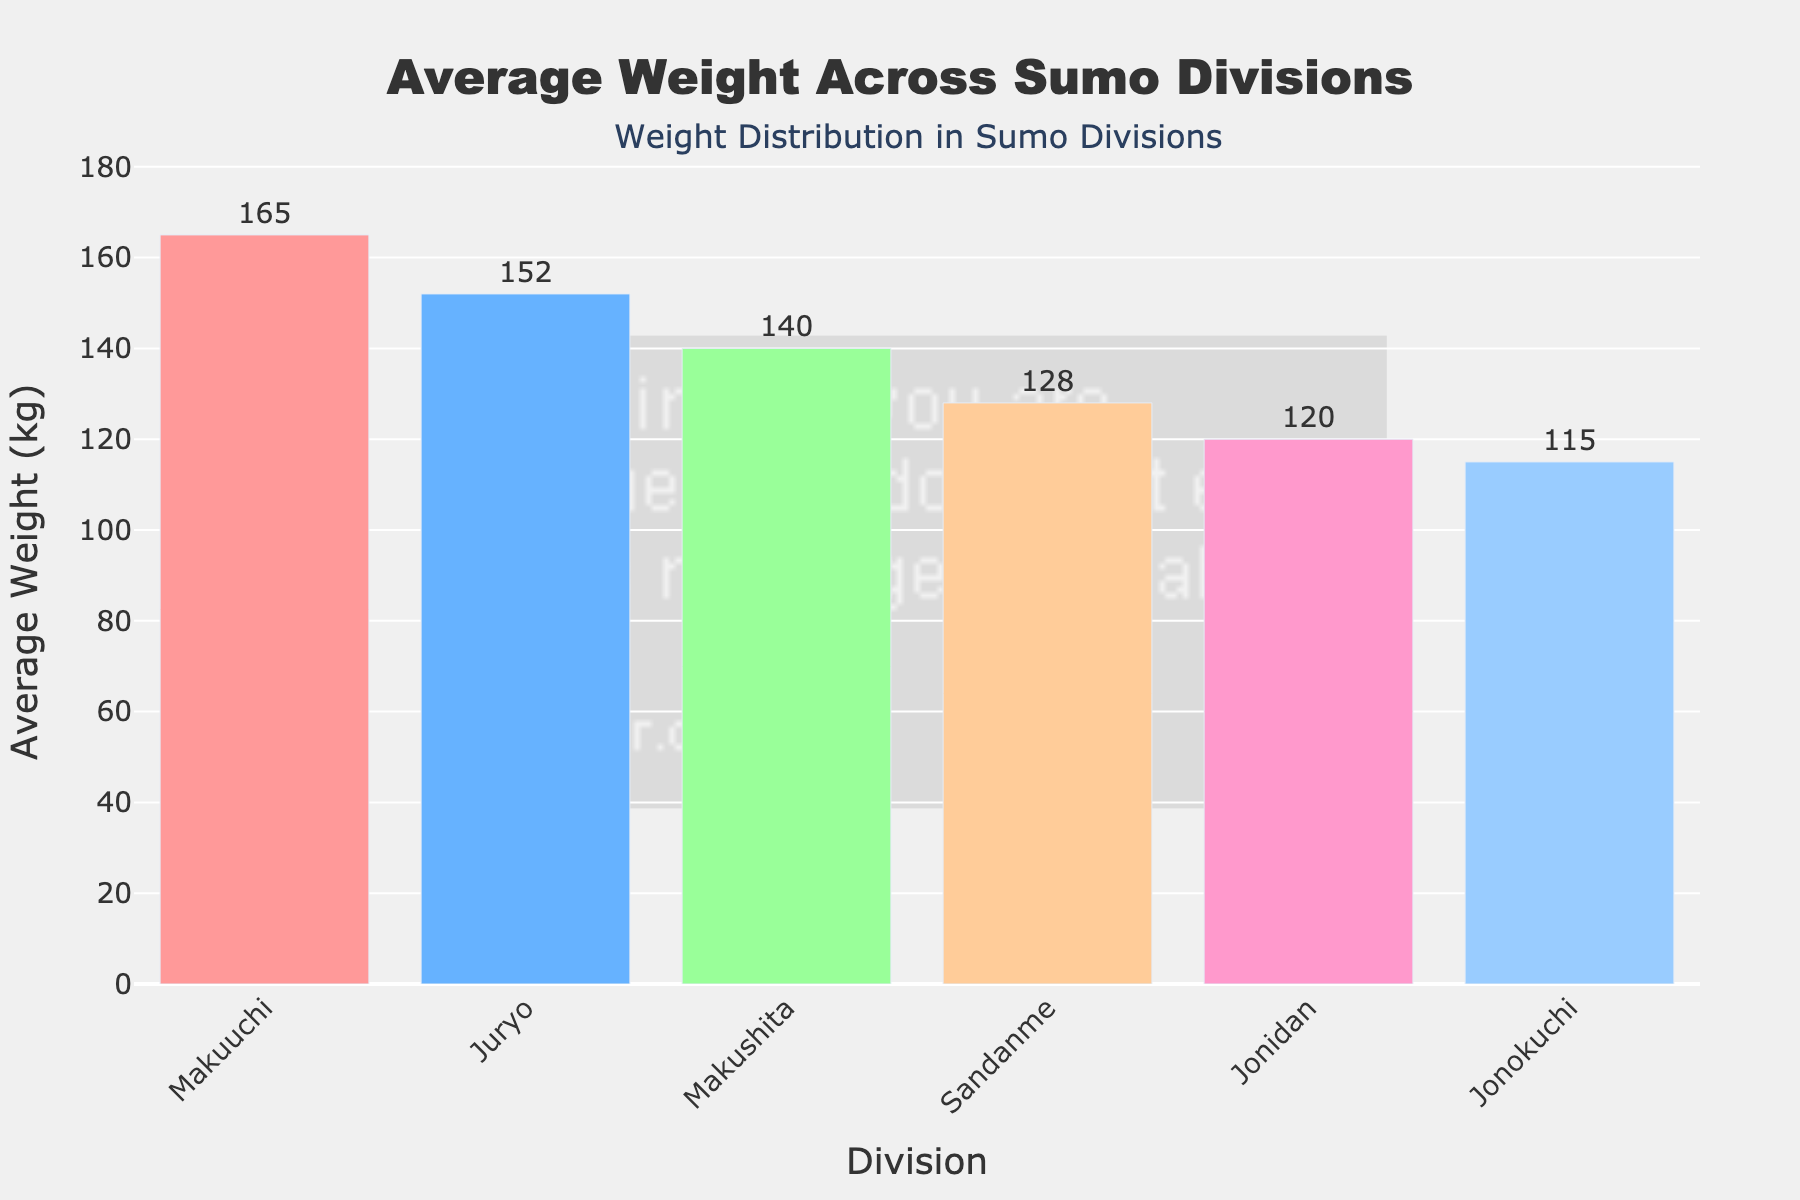How do the average weights of Makuuchi and Juryo divisions compare? From the figure, the average weight of Makuuchi division is 165 kg and that of Juryo division is 152 kg. By comparing these, we see that Makuuchi’s average weight is higher.
Answer: Makuuchi is heavier What is the difference in average weight between Makushita and Jonokuchi divisions? The average weights are 140 kg for Makushita and 115 kg for Jonokuchi. Subtracting these values: 140 - 115 = 25 kg.
Answer: 25 kg Which division has the lightest average weight? Looking at the bar lengths and hover text, the shortest bar corresponds to Jonokuchi, which has the lightest average weight of 115 kg.
Answer: Jonokuchi What is the sum of the average weights of Jonidan and Sandanme divisions? The figure shows Jonidan's average weight as 120 kg and Sandanme's as 128 kg. Adding these: 120 + 128 = 248 kg.
Answer: 248 kg Is the average weight of Makushita division greater than that of Sandanme? Comparing the heights of the bars for Makushita (140 kg) and Sandanme (128 kg), where Makushita's bar is taller, indicating a greater average weight.
Answer: Yes What is the median average weight of the divisions? Arrange the average weights [165, 152, 140, 128, 120, 115] and find the middle value. Since there are 6 values, the median is the average of the 3rd and 4th values: (140 + 128) / 2 = 134 kg.
Answer: 134 kg How many divisions have an average weight below 150 kg? By inspecting the height of each bar, the divisions below 150 kg are Makushita, Sandanme, Jonidan, and Jonokuchi, totaling 4 divisions.
Answer: 4 What is the average weight of the top three divisions? The top three divisions are Makuuchi (165 kg), Juryo (152 kg), and Makushita (140 kg). Calculate their average: (165 + 152 + 140) / 3 ≈ 152.33 kg.
Answer: 152.33 kg Which division shows the most considerable difference in average weight compared to the Jonokuchi division? By comparing differences, Makuuchi (165 kg) - Jonokuchi (115 kg) = 50 kg, which is the highest difference among the divisions.
Answer: Makuuchi Which division's average weight is represented in blue color on the bar chart? By looking at the colors on the chart, the division represented by the blue bar has an average weight of 152 kg, which corresponds to the Juryo division.
Answer: Juryo 